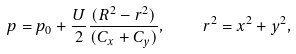Convert formula to latex. <formula><loc_0><loc_0><loc_500><loc_500>p = p _ { 0 } + \frac { U } { 2 } \frac { ( R ^ { 2 } - r ^ { 2 } ) } { ( C _ { x } + C _ { y } ) } , \quad r ^ { 2 } = x ^ { 2 } + y ^ { 2 } ,</formula> 